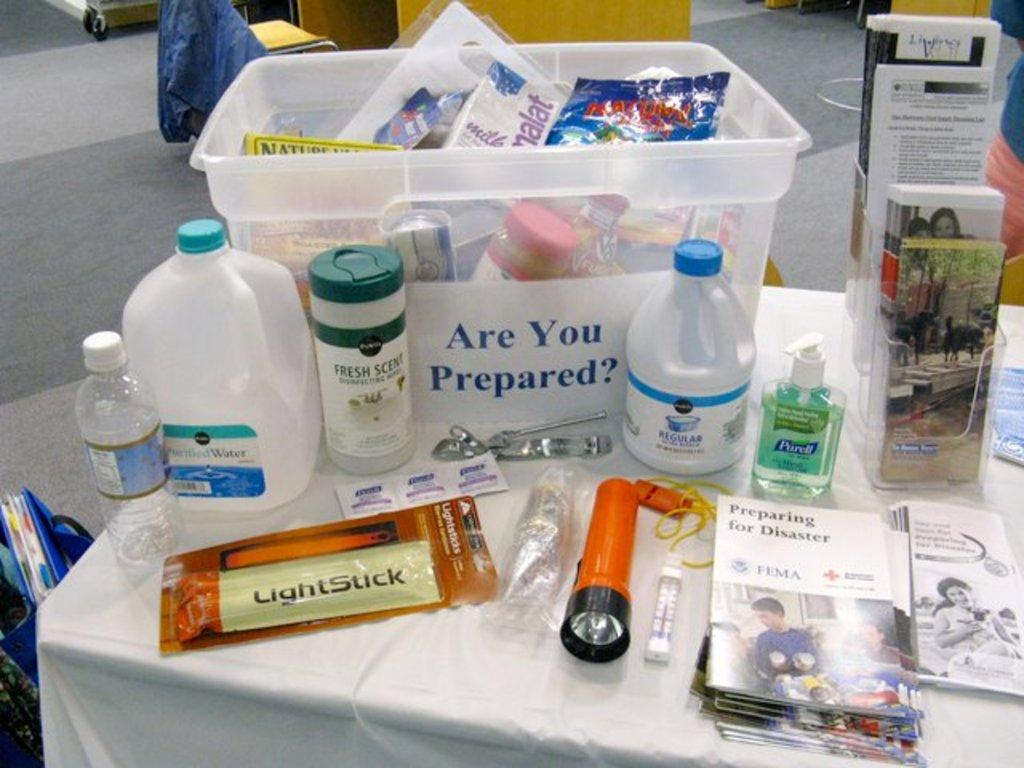What objects are on the table in the image? There are bottles, papers, and a torch on the table in the image. What type of wall can be seen in the background of the image? There is a wooden wall in the background of the image. What type of watch is being used to stop the mass in the image? There is no watch, mass, or any indication of stopping in the image. 